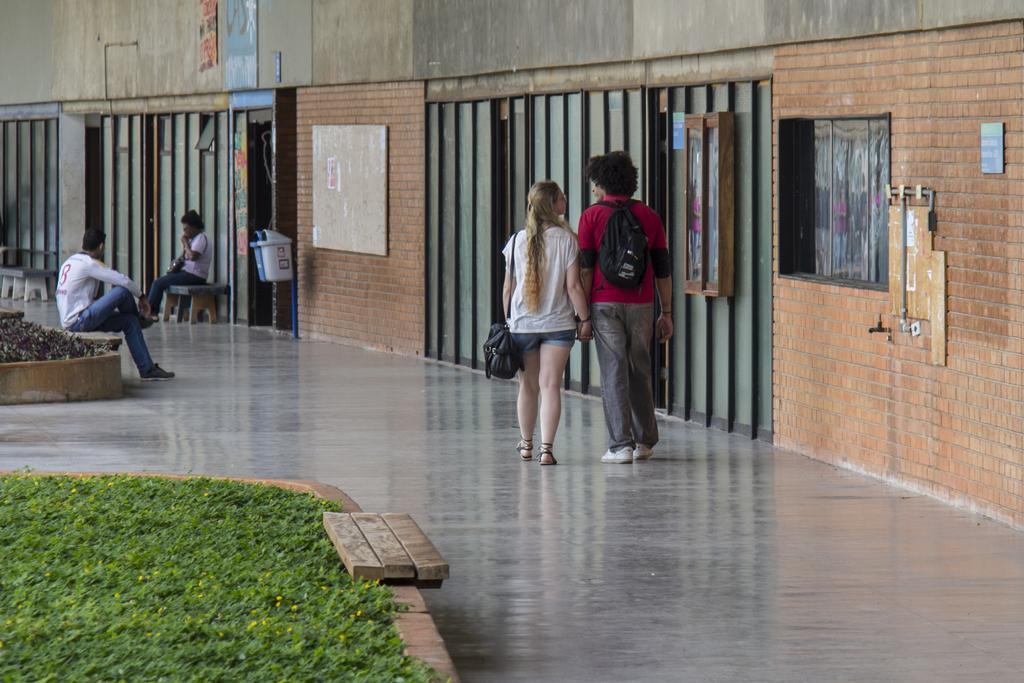In one or two sentences, can you explain what this image depicts? In this image there are two persons walking on the surface of the floor and there are two persons seated on chairs, in the background of the image there is grass and small plants and notice board and trash cans. 